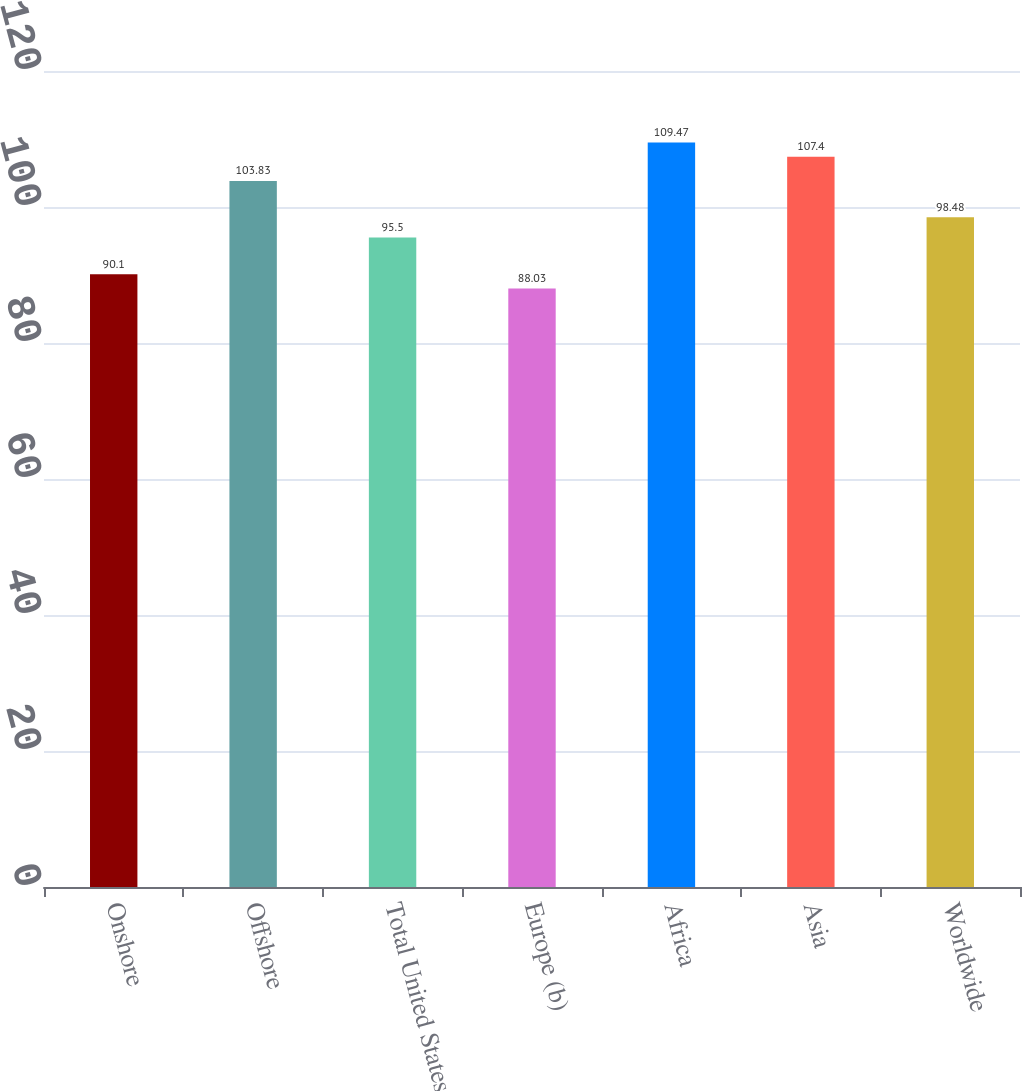<chart> <loc_0><loc_0><loc_500><loc_500><bar_chart><fcel>Onshore<fcel>Offshore<fcel>Total United States<fcel>Europe (b)<fcel>Africa<fcel>Asia<fcel>Worldwide<nl><fcel>90.1<fcel>103.83<fcel>95.5<fcel>88.03<fcel>109.47<fcel>107.4<fcel>98.48<nl></chart> 